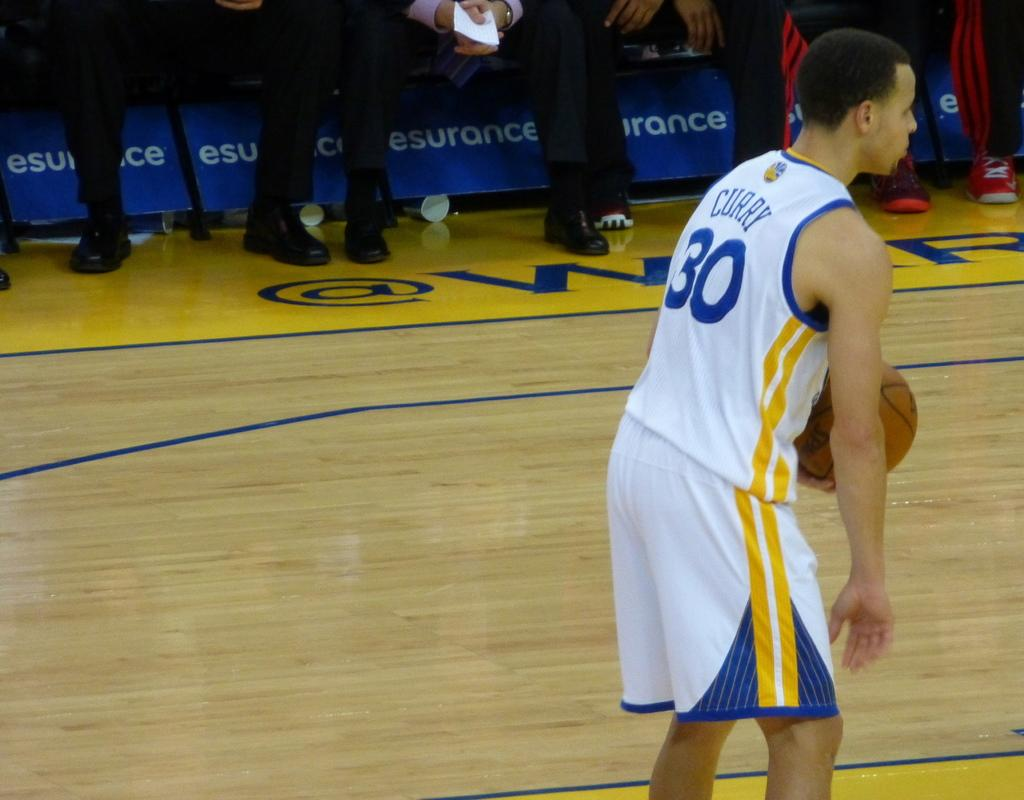<image>
Render a clear and concise summary of the photo. a player of basketball with the number 30 on standing 